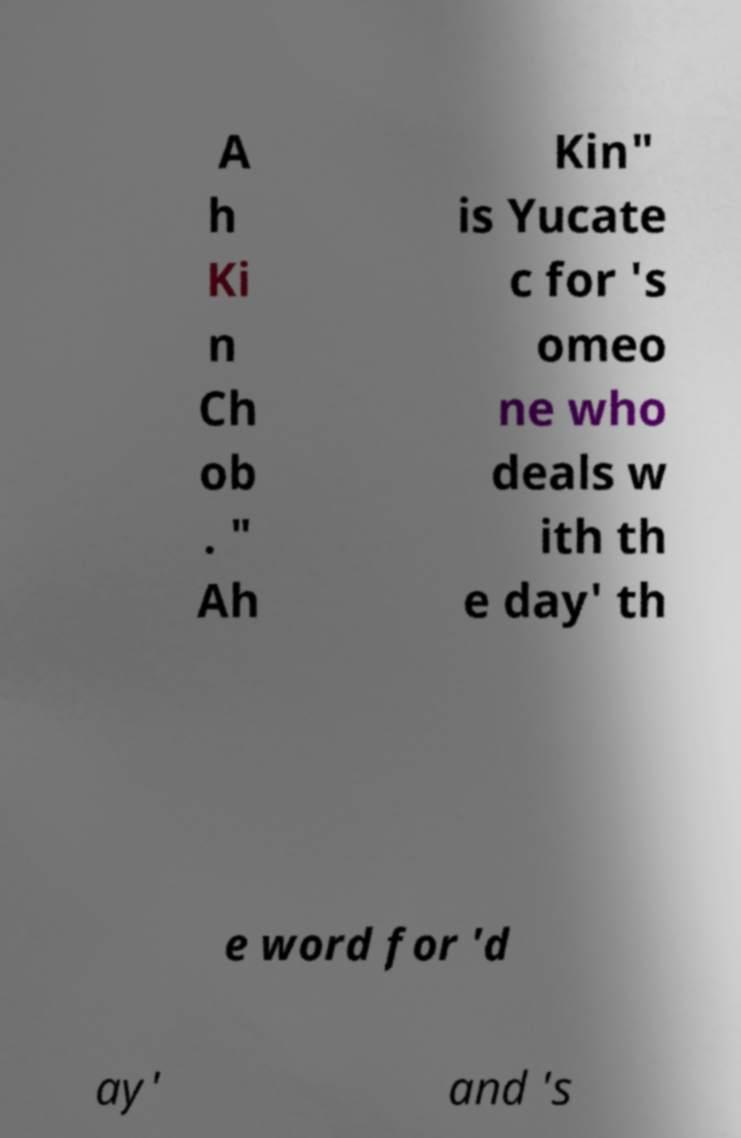Please identify and transcribe the text found in this image. A h Ki n Ch ob . " Ah Kin" is Yucate c for 's omeo ne who deals w ith th e day' th e word for 'd ay' and 's 